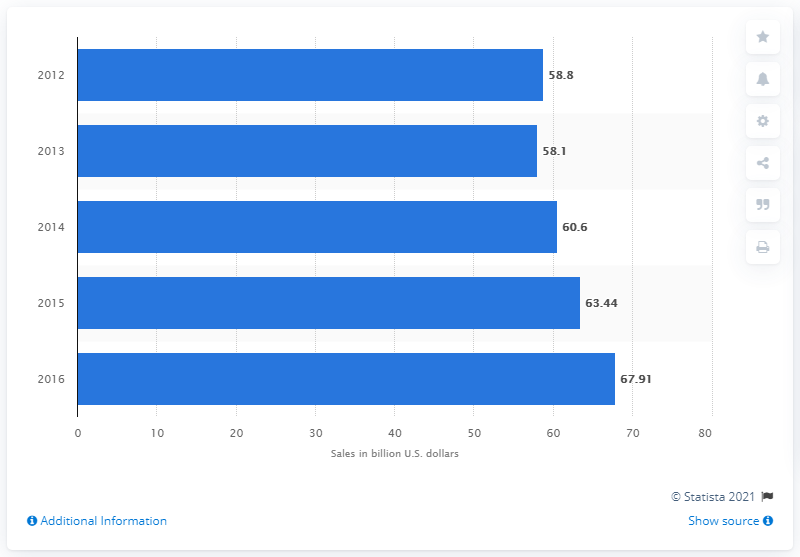Identify some key points in this picture. The total sales of the recreational fishing industry in 2016 were $67.91 million. 